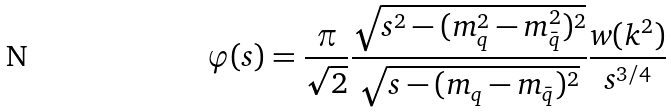Convert formula to latex. <formula><loc_0><loc_0><loc_500><loc_500>\varphi ( s ) = \frac { \pi } { \sqrt { 2 } } \frac { \sqrt { s ^ { 2 } - ( m _ { q } ^ { 2 } - m _ { \bar { q } } ^ { 2 } ) ^ { 2 } } } { \sqrt { s - ( m _ { q } - m _ { \bar { q } } ) ^ { 2 } } } \frac { w ( k ^ { 2 } ) } { s ^ { 3 / 4 } }</formula> 